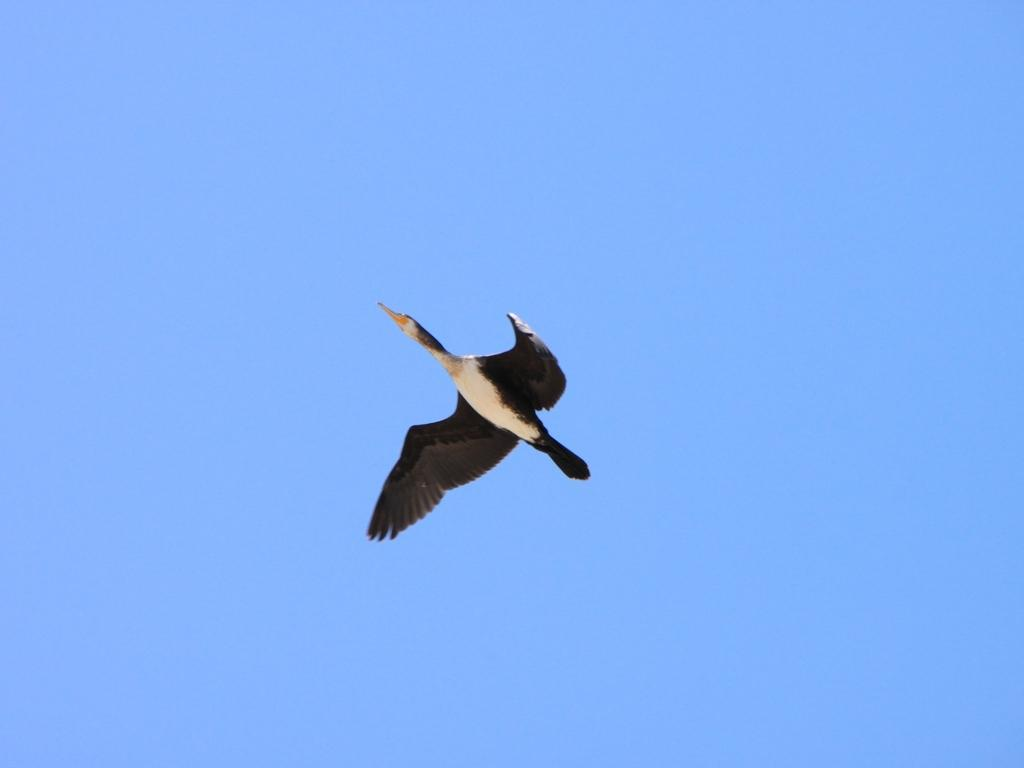What type of animal is in the image? There is a bird in the image. What is the bird doing in the image? The bird is flying. What can be seen in the background of the image? The sky is visible in the image. What type of board is the bird using for its voyage in the image? There is no board or voyage present in the image; the bird is simply flying in the sky. 